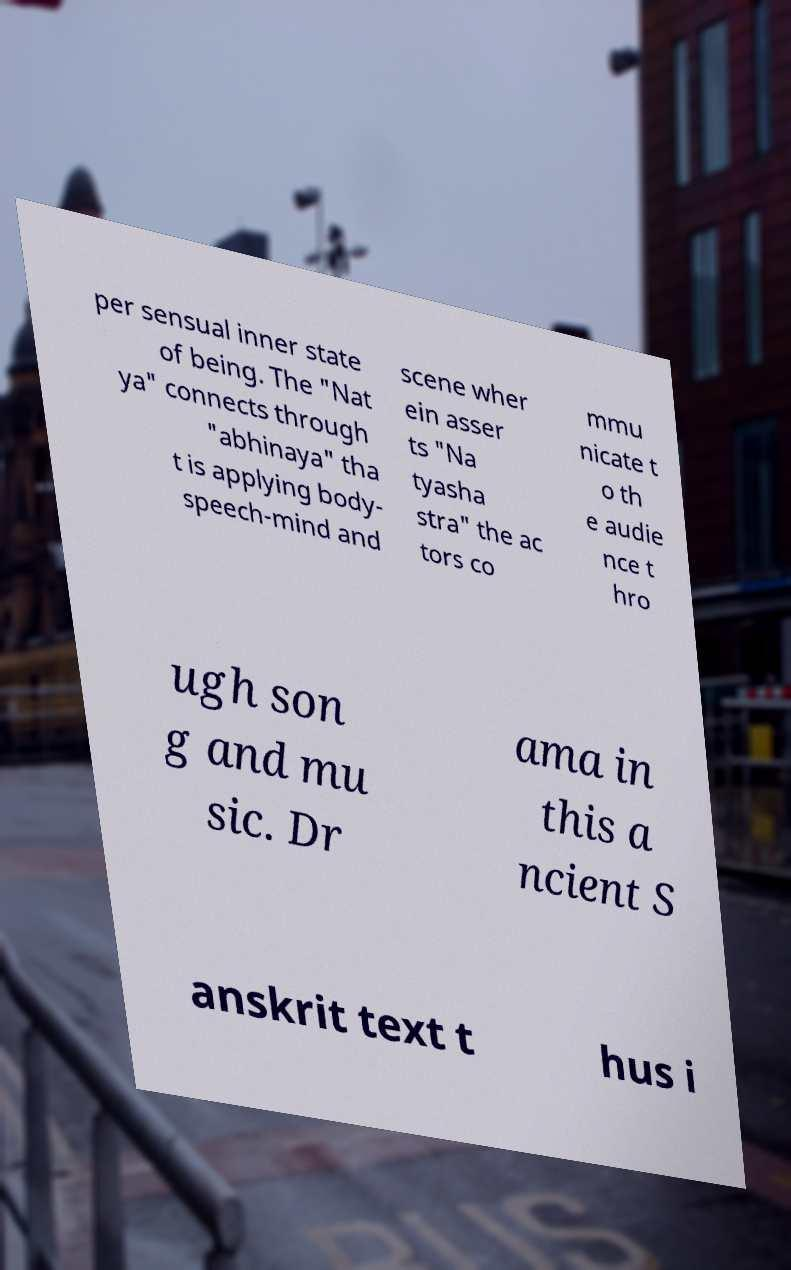I need the written content from this picture converted into text. Can you do that? per sensual inner state of being. The "Nat ya" connects through "abhinaya" tha t is applying body- speech-mind and scene wher ein asser ts "Na tyasha stra" the ac tors co mmu nicate t o th e audie nce t hro ugh son g and mu sic. Dr ama in this a ncient S anskrit text t hus i 